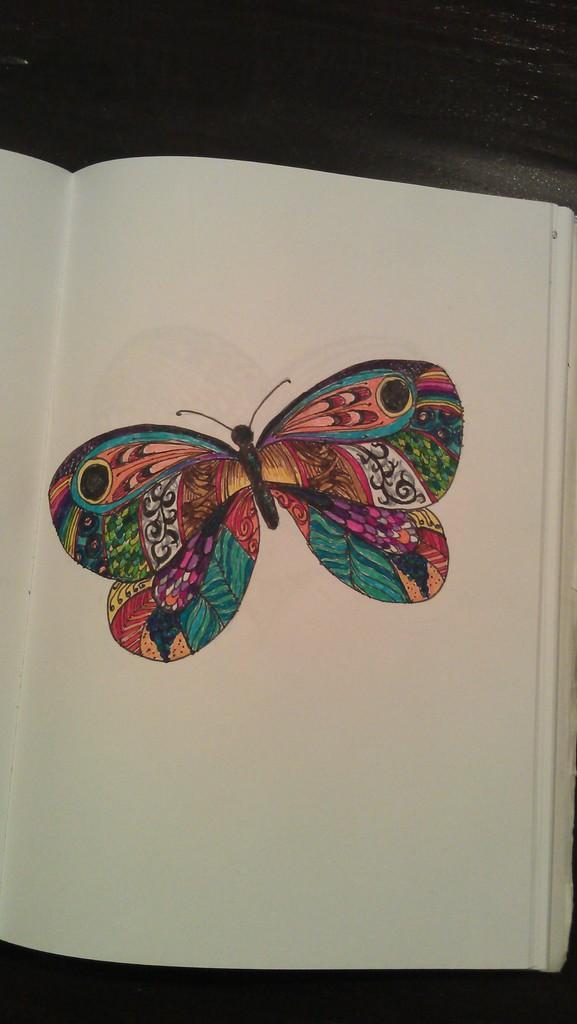In one or two sentences, can you explain what this image depicts? In this image I can see a colorful butterfly on the book. Background is in black color. 